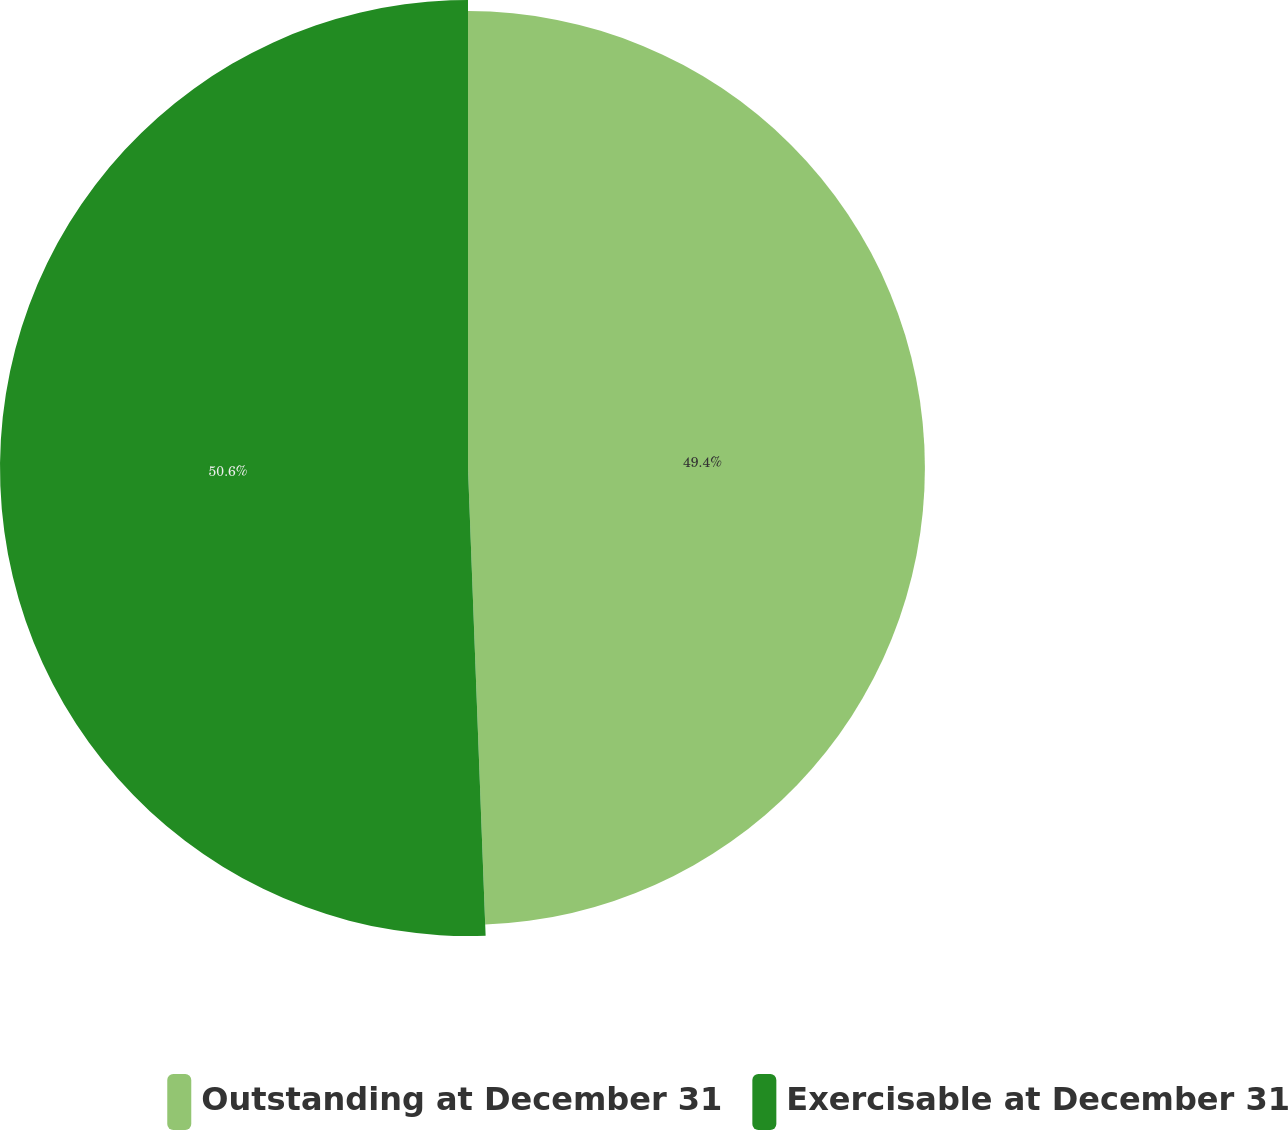Convert chart. <chart><loc_0><loc_0><loc_500><loc_500><pie_chart><fcel>Outstanding at December 31<fcel>Exercisable at December 31<nl><fcel>49.4%<fcel>50.6%<nl></chart> 